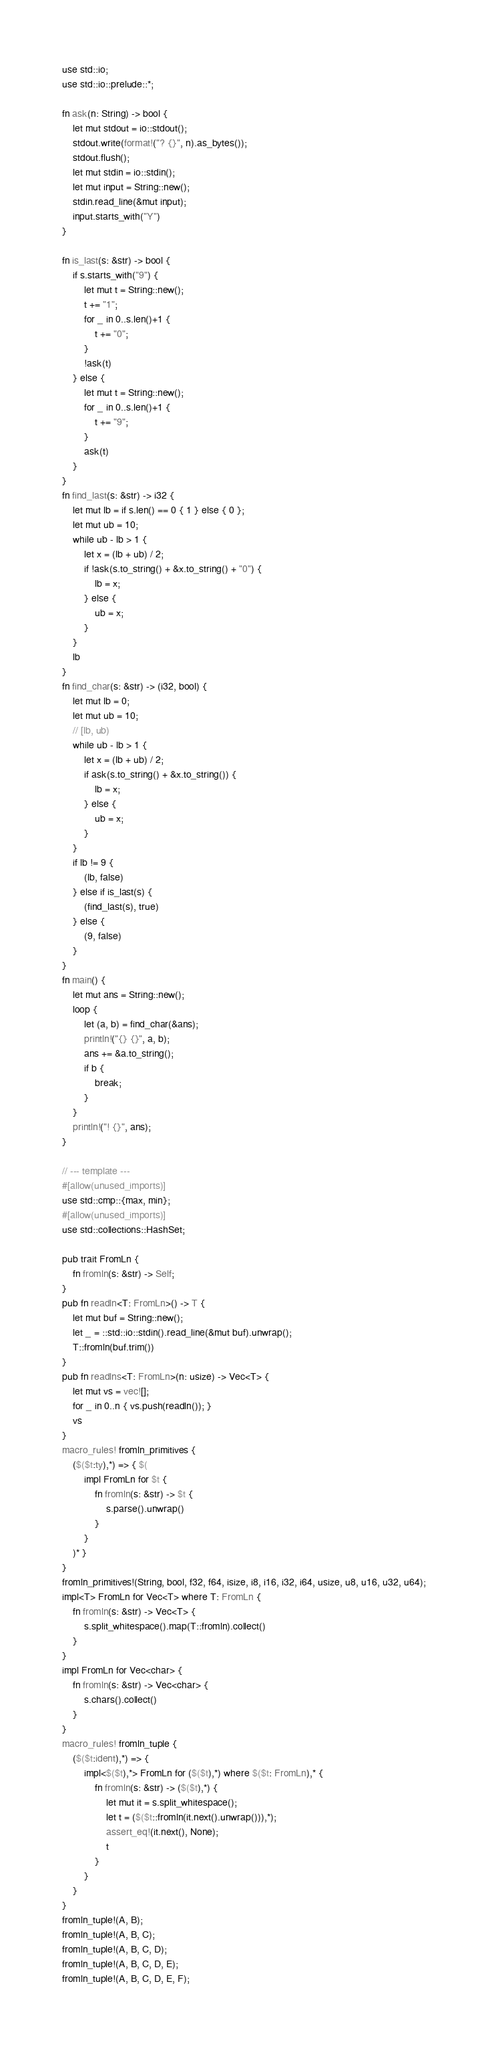Convert code to text. <code><loc_0><loc_0><loc_500><loc_500><_Rust_>use std::io;
use std::io::prelude::*;

fn ask(n: String) -> bool {
    let mut stdout = io::stdout();
    stdout.write(format!("? {}", n).as_bytes());
    stdout.flush();
    let mut stdin = io::stdin();
    let mut input = String::new();
    stdin.read_line(&mut input);
    input.starts_with("Y")
}

fn is_last(s: &str) -> bool {
    if s.starts_with("9") {
        let mut t = String::new();
        t += "1";
        for _ in 0..s.len()+1 {
            t += "0";
        }
        !ask(t)
    } else {
        let mut t = String::new();
        for _ in 0..s.len()+1 {
            t += "9";
        }
        ask(t)
    }
}
fn find_last(s: &str) -> i32 {
    let mut lb = if s.len() == 0 { 1 } else { 0 };
    let mut ub = 10;
    while ub - lb > 1 {
        let x = (lb + ub) / 2;
        if !ask(s.to_string() + &x.to_string() + "0") {
            lb = x;
        } else {
            ub = x;
        }
    }
    lb
}
fn find_char(s: &str) -> (i32, bool) {
    let mut lb = 0;
    let mut ub = 10;
    // [lb, ub)
    while ub - lb > 1 {
        let x = (lb + ub) / 2;
        if ask(s.to_string() + &x.to_string()) {
            lb = x;
        } else {
            ub = x;
        }
    }
    if lb != 9 {
        (lb, false)
    } else if is_last(s) {
        (find_last(s), true)
    } else {
        (9, false)
    }
}
fn main() {
    let mut ans = String::new();
    loop {
        let (a, b) = find_char(&ans);
        println!("{} {}", a, b);
        ans += &a.to_string();
        if b {
            break;
        }
    }
    println!("! {}", ans);
}

// --- template ---
#[allow(unused_imports)]
use std::cmp::{max, min};
#[allow(unused_imports)]
use std::collections::HashSet;

pub trait FromLn {
    fn fromln(s: &str) -> Self;
}
pub fn readln<T: FromLn>() -> T {
    let mut buf = String::new();
    let _ = ::std::io::stdin().read_line(&mut buf).unwrap();
    T::fromln(buf.trim())
}
pub fn readlns<T: FromLn>(n: usize) -> Vec<T> {
    let mut vs = vec![];
    for _ in 0..n { vs.push(readln()); }
    vs
}
macro_rules! fromln_primitives {
    ($($t:ty),*) => { $(
        impl FromLn for $t {
            fn fromln(s: &str) -> $t {
                s.parse().unwrap()
            }
        }
    )* }
}
fromln_primitives!(String, bool, f32, f64, isize, i8, i16, i32, i64, usize, u8, u16, u32, u64);
impl<T> FromLn for Vec<T> where T: FromLn {
    fn fromln(s: &str) -> Vec<T> {
        s.split_whitespace().map(T::fromln).collect()
    }
}
impl FromLn for Vec<char> {
    fn fromln(s: &str) -> Vec<char> {
        s.chars().collect()
    }
}
macro_rules! fromln_tuple {
    ($($t:ident),*) => {
        impl<$($t),*> FromLn for ($($t),*) where $($t: FromLn),* {
            fn fromln(s: &str) -> ($($t),*) {
                let mut it = s.split_whitespace();
                let t = ($($t::fromln(it.next().unwrap())),*);
                assert_eq!(it.next(), None);
                t
            }
        }
    }
}
fromln_tuple!(A, B);
fromln_tuple!(A, B, C);
fromln_tuple!(A, B, C, D);
fromln_tuple!(A, B, C, D, E);
fromln_tuple!(A, B, C, D, E, F);</code> 